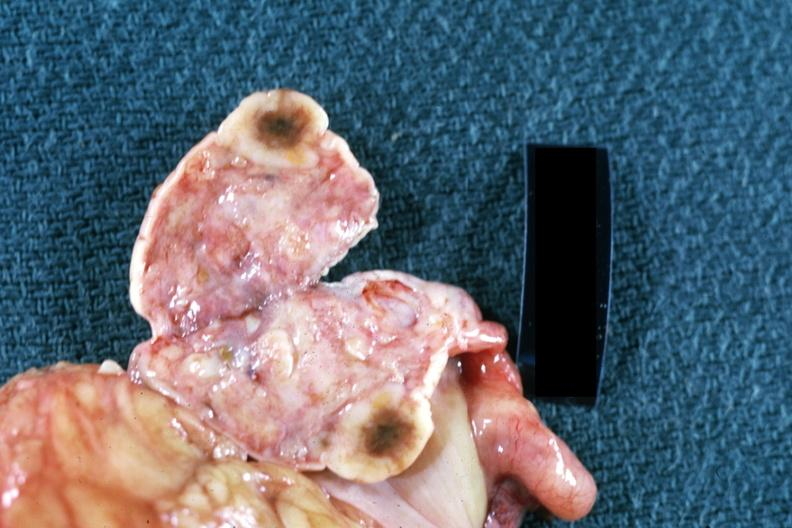s female reproductive present?
Answer the question using a single word or phrase. Yes 